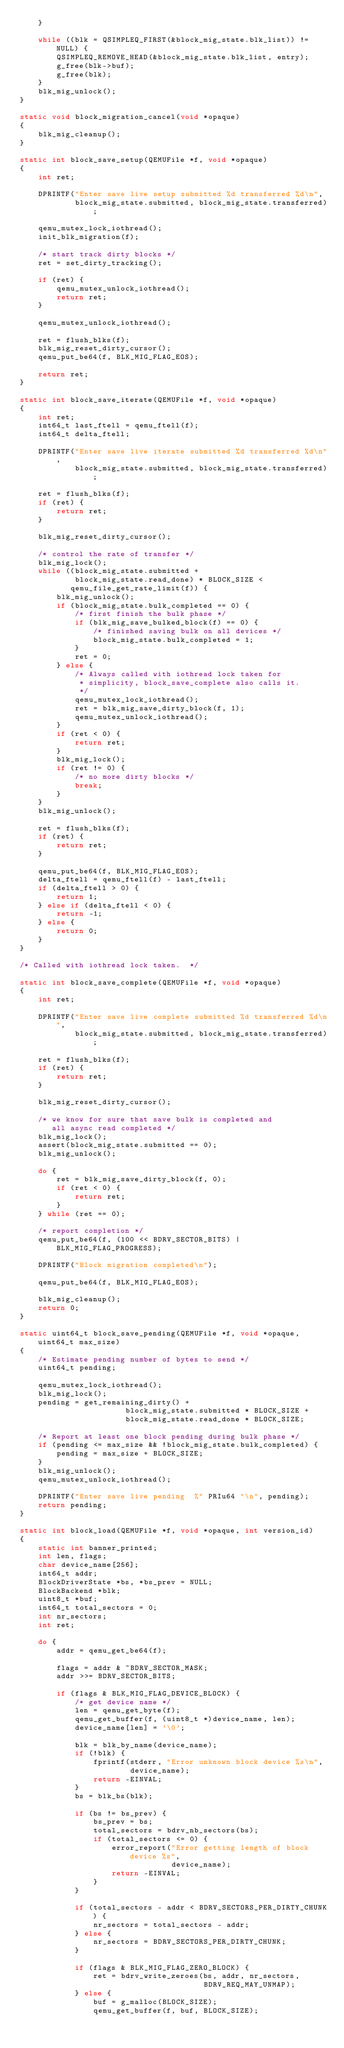<code> <loc_0><loc_0><loc_500><loc_500><_C_>    }

    while ((blk = QSIMPLEQ_FIRST(&block_mig_state.blk_list)) != NULL) {
        QSIMPLEQ_REMOVE_HEAD(&block_mig_state.blk_list, entry);
        g_free(blk->buf);
        g_free(blk);
    }
    blk_mig_unlock();
}

static void block_migration_cancel(void *opaque)
{
    blk_mig_cleanup();
}

static int block_save_setup(QEMUFile *f, void *opaque)
{
    int ret;

    DPRINTF("Enter save live setup submitted %d transferred %d\n",
            block_mig_state.submitted, block_mig_state.transferred);

    qemu_mutex_lock_iothread();
    init_blk_migration(f);

    /* start track dirty blocks */
    ret = set_dirty_tracking();

    if (ret) {
        qemu_mutex_unlock_iothread();
        return ret;
    }

    qemu_mutex_unlock_iothread();

    ret = flush_blks(f);
    blk_mig_reset_dirty_cursor();
    qemu_put_be64(f, BLK_MIG_FLAG_EOS);

    return ret;
}

static int block_save_iterate(QEMUFile *f, void *opaque)
{
    int ret;
    int64_t last_ftell = qemu_ftell(f);
    int64_t delta_ftell;

    DPRINTF("Enter save live iterate submitted %d transferred %d\n",
            block_mig_state.submitted, block_mig_state.transferred);

    ret = flush_blks(f);
    if (ret) {
        return ret;
    }

    blk_mig_reset_dirty_cursor();

    /* control the rate of transfer */
    blk_mig_lock();
    while ((block_mig_state.submitted +
            block_mig_state.read_done) * BLOCK_SIZE <
           qemu_file_get_rate_limit(f)) {
        blk_mig_unlock();
        if (block_mig_state.bulk_completed == 0) {
            /* first finish the bulk phase */
            if (blk_mig_save_bulked_block(f) == 0) {
                /* finished saving bulk on all devices */
                block_mig_state.bulk_completed = 1;
            }
            ret = 0;
        } else {
            /* Always called with iothread lock taken for
             * simplicity, block_save_complete also calls it.
             */
            qemu_mutex_lock_iothread();
            ret = blk_mig_save_dirty_block(f, 1);
            qemu_mutex_unlock_iothread();
        }
        if (ret < 0) {
            return ret;
        }
        blk_mig_lock();
        if (ret != 0) {
            /* no more dirty blocks */
            break;
        }
    }
    blk_mig_unlock();

    ret = flush_blks(f);
    if (ret) {
        return ret;
    }

    qemu_put_be64(f, BLK_MIG_FLAG_EOS);
    delta_ftell = qemu_ftell(f) - last_ftell;
    if (delta_ftell > 0) {
        return 1;
    } else if (delta_ftell < 0) {
        return -1;
    } else {
        return 0;
    }
}

/* Called with iothread lock taken.  */

static int block_save_complete(QEMUFile *f, void *opaque)
{
    int ret;

    DPRINTF("Enter save live complete submitted %d transferred %d\n",
            block_mig_state.submitted, block_mig_state.transferred);

    ret = flush_blks(f);
    if (ret) {
        return ret;
    }

    blk_mig_reset_dirty_cursor();

    /* we know for sure that save bulk is completed and
       all async read completed */
    blk_mig_lock();
    assert(block_mig_state.submitted == 0);
    blk_mig_unlock();

    do {
        ret = blk_mig_save_dirty_block(f, 0);
        if (ret < 0) {
            return ret;
        }
    } while (ret == 0);

    /* report completion */
    qemu_put_be64(f, (100 << BDRV_SECTOR_BITS) | BLK_MIG_FLAG_PROGRESS);

    DPRINTF("Block migration completed\n");

    qemu_put_be64(f, BLK_MIG_FLAG_EOS);

    blk_mig_cleanup();
    return 0;
}

static uint64_t block_save_pending(QEMUFile *f, void *opaque, uint64_t max_size)
{
    /* Estimate pending number of bytes to send */
    uint64_t pending;

    qemu_mutex_lock_iothread();
    blk_mig_lock();
    pending = get_remaining_dirty() +
                       block_mig_state.submitted * BLOCK_SIZE +
                       block_mig_state.read_done * BLOCK_SIZE;

    /* Report at least one block pending during bulk phase */
    if (pending <= max_size && !block_mig_state.bulk_completed) {
        pending = max_size + BLOCK_SIZE;
    }
    blk_mig_unlock();
    qemu_mutex_unlock_iothread();

    DPRINTF("Enter save live pending  %" PRIu64 "\n", pending);
    return pending;
}

static int block_load(QEMUFile *f, void *opaque, int version_id)
{
    static int banner_printed;
    int len, flags;
    char device_name[256];
    int64_t addr;
    BlockDriverState *bs, *bs_prev = NULL;
    BlockBackend *blk;
    uint8_t *buf;
    int64_t total_sectors = 0;
    int nr_sectors;
    int ret;

    do {
        addr = qemu_get_be64(f);

        flags = addr & ~BDRV_SECTOR_MASK;
        addr >>= BDRV_SECTOR_BITS;

        if (flags & BLK_MIG_FLAG_DEVICE_BLOCK) {
            /* get device name */
            len = qemu_get_byte(f);
            qemu_get_buffer(f, (uint8_t *)device_name, len);
            device_name[len] = '\0';

            blk = blk_by_name(device_name);
            if (!blk) {
                fprintf(stderr, "Error unknown block device %s\n",
                        device_name);
                return -EINVAL;
            }
            bs = blk_bs(blk);

            if (bs != bs_prev) {
                bs_prev = bs;
                total_sectors = bdrv_nb_sectors(bs);
                if (total_sectors <= 0) {
                    error_report("Error getting length of block device %s",
                                 device_name);
                    return -EINVAL;
                }
            }

            if (total_sectors - addr < BDRV_SECTORS_PER_DIRTY_CHUNK) {
                nr_sectors = total_sectors - addr;
            } else {
                nr_sectors = BDRV_SECTORS_PER_DIRTY_CHUNK;
            }

            if (flags & BLK_MIG_FLAG_ZERO_BLOCK) {
                ret = bdrv_write_zeroes(bs, addr, nr_sectors,
                                        BDRV_REQ_MAY_UNMAP);
            } else {
                buf = g_malloc(BLOCK_SIZE);
                qemu_get_buffer(f, buf, BLOCK_SIZE);</code> 